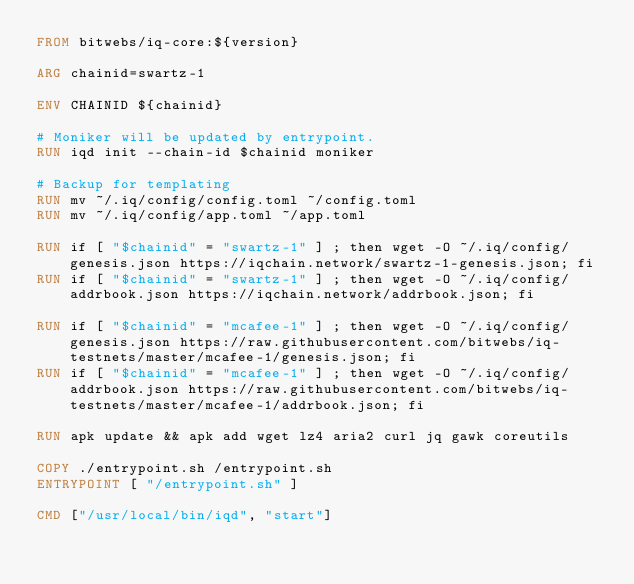Convert code to text. <code><loc_0><loc_0><loc_500><loc_500><_Dockerfile_>FROM bitwebs/iq-core:${version}

ARG chainid=swartz-1

ENV CHAINID ${chainid}

# Moniker will be updated by entrypoint.
RUN iqd init --chain-id $chainid moniker

# Backup for templating
RUN mv ~/.iq/config/config.toml ~/config.toml
RUN mv ~/.iq/config/app.toml ~/app.toml

RUN if [ "$chainid" = "swartz-1" ] ; then wget -O ~/.iq/config/genesis.json https://iqchain.network/swartz-1-genesis.json; fi
RUN if [ "$chainid" = "swartz-1" ] ; then wget -O ~/.iq/config/addrbook.json https://iqchain.network/addrbook.json; fi

RUN if [ "$chainid" = "mcafee-1" ] ; then wget -O ~/.iq/config/genesis.json https://raw.githubusercontent.com/bitwebs/iq-testnets/master/mcafee-1/genesis.json; fi
RUN if [ "$chainid" = "mcafee-1" ] ; then wget -O ~/.iq/config/addrbook.json https://raw.githubusercontent.com/bitwebs/iq-testnets/master/mcafee-1/addrbook.json; fi

RUN apk update && apk add wget lz4 aria2 curl jq gawk coreutils

COPY ./entrypoint.sh /entrypoint.sh
ENTRYPOINT [ "/entrypoint.sh" ]

CMD ["/usr/local/bin/iqd", "start"]</code> 